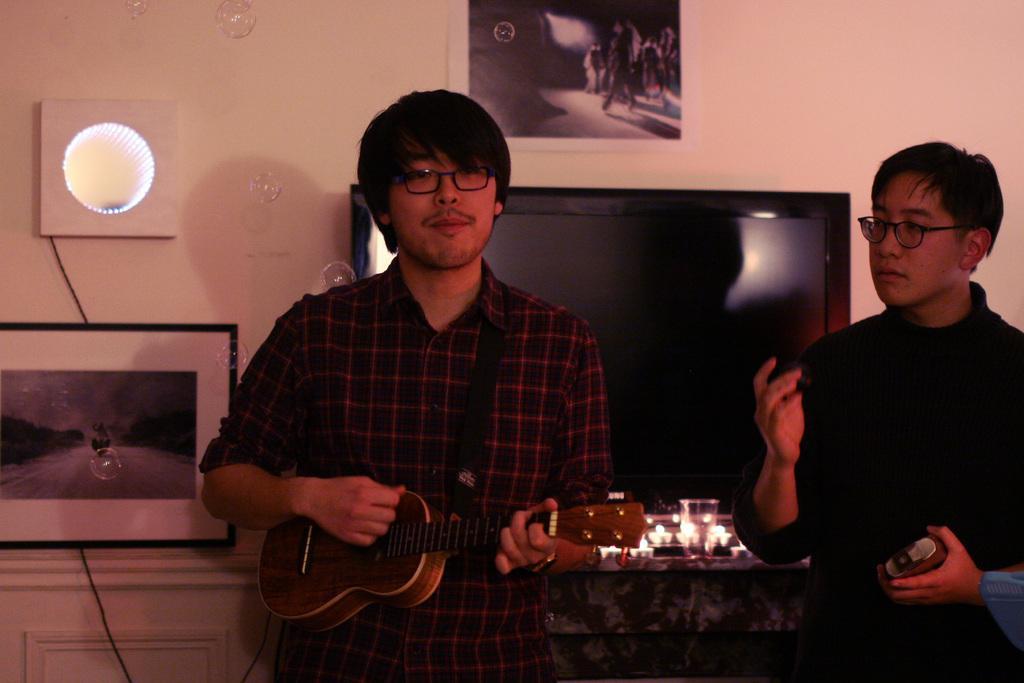In one or two sentences, can you explain what this image depicts? In this image I see a man who is standing and holding a guitar, I can also see another man beside to him and he is also standing. In the background I see wall, a photo frame, television and a paper. 